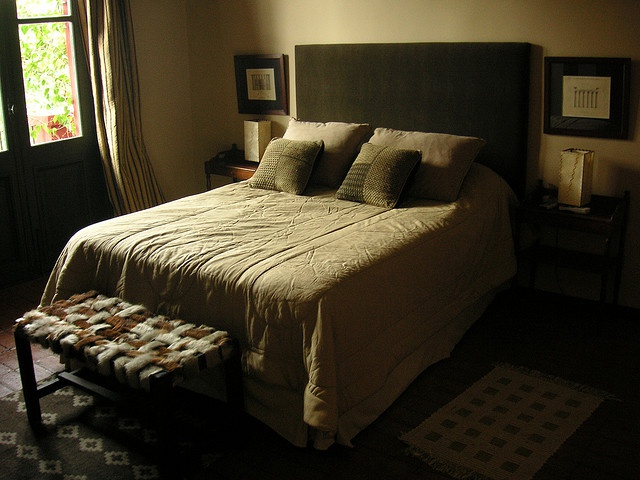Describe the objects in this image and their specific colors. I can see a bed in black, tan, khaki, and olive tones in this image. 